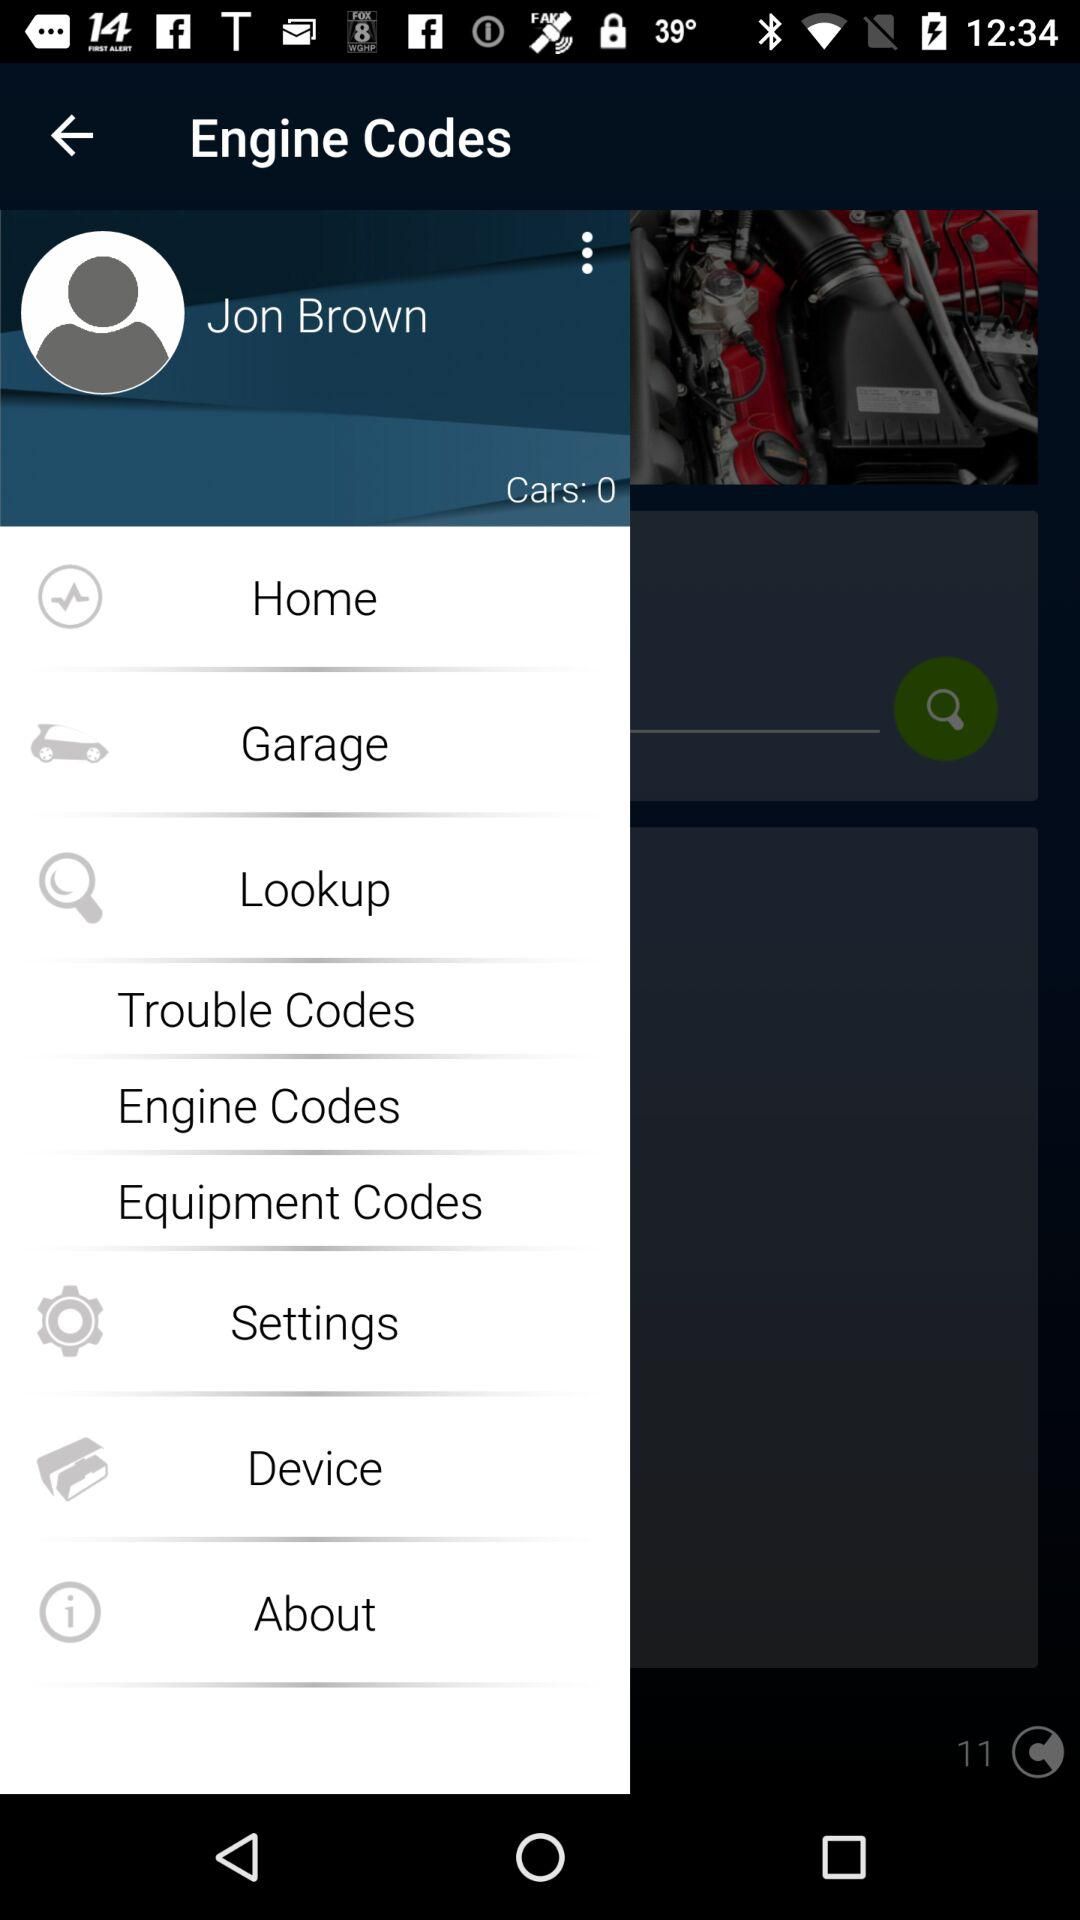What is the name of the user? The name of the user is Jon Brown. 